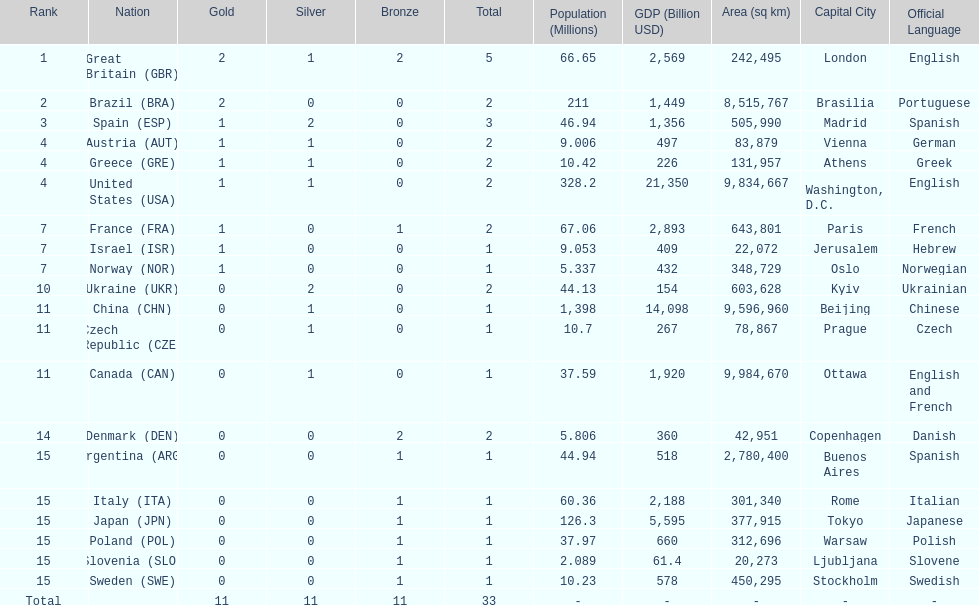What was the number of silver medals won by ukraine? 2. 